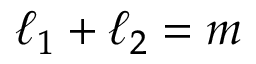<formula> <loc_0><loc_0><loc_500><loc_500>\ell _ { 1 } + \ell _ { 2 } = m</formula> 